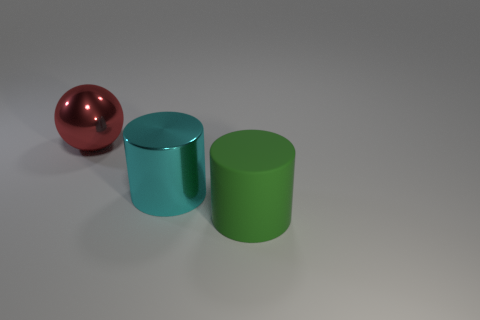Is there anything else that has the same material as the green cylinder?
Make the answer very short. No. Are there any other red objects that have the same shape as the big rubber object?
Your answer should be compact. No. What number of big things are both in front of the large cyan metal object and behind the cyan shiny object?
Provide a succinct answer. 0. How many things are either matte things or large objects behind the large green matte cylinder?
Ensure brevity in your answer.  3. What color is the cylinder that is behind the big rubber object?
Provide a short and direct response. Cyan. What number of objects are either metallic things behind the big cyan object or small blue cylinders?
Provide a short and direct response. 1. There is a rubber cylinder that is the same size as the red shiny thing; what color is it?
Offer a very short reply. Green. Is the number of balls that are on the left side of the matte thing greater than the number of tiny cyan cubes?
Your response must be concise. Yes. What number of other objects are there of the same size as the metal cylinder?
Ensure brevity in your answer.  2. There is a cylinder that is on the left side of the large matte object in front of the cyan metal cylinder; is there a red sphere behind it?
Provide a short and direct response. Yes. 